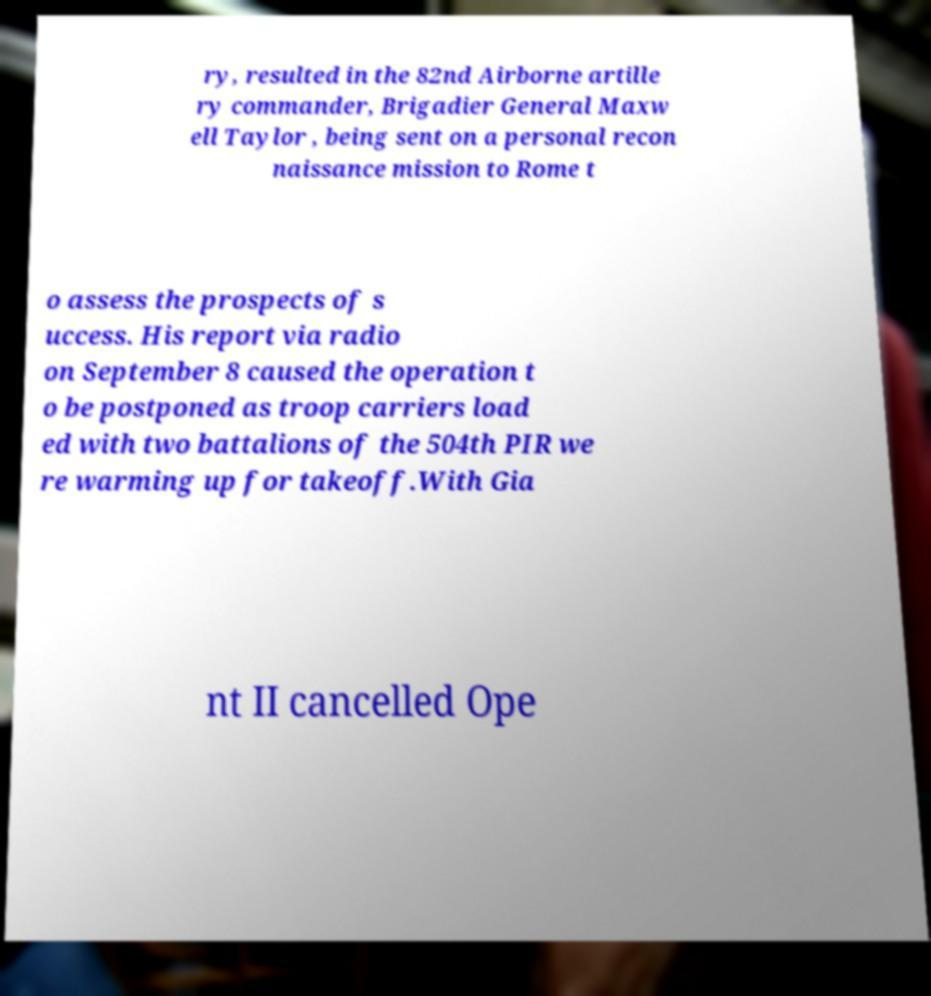I need the written content from this picture converted into text. Can you do that? ry, resulted in the 82nd Airborne artille ry commander, Brigadier General Maxw ell Taylor , being sent on a personal recon naissance mission to Rome t o assess the prospects of s uccess. His report via radio on September 8 caused the operation t o be postponed as troop carriers load ed with two battalions of the 504th PIR we re warming up for takeoff.With Gia nt II cancelled Ope 